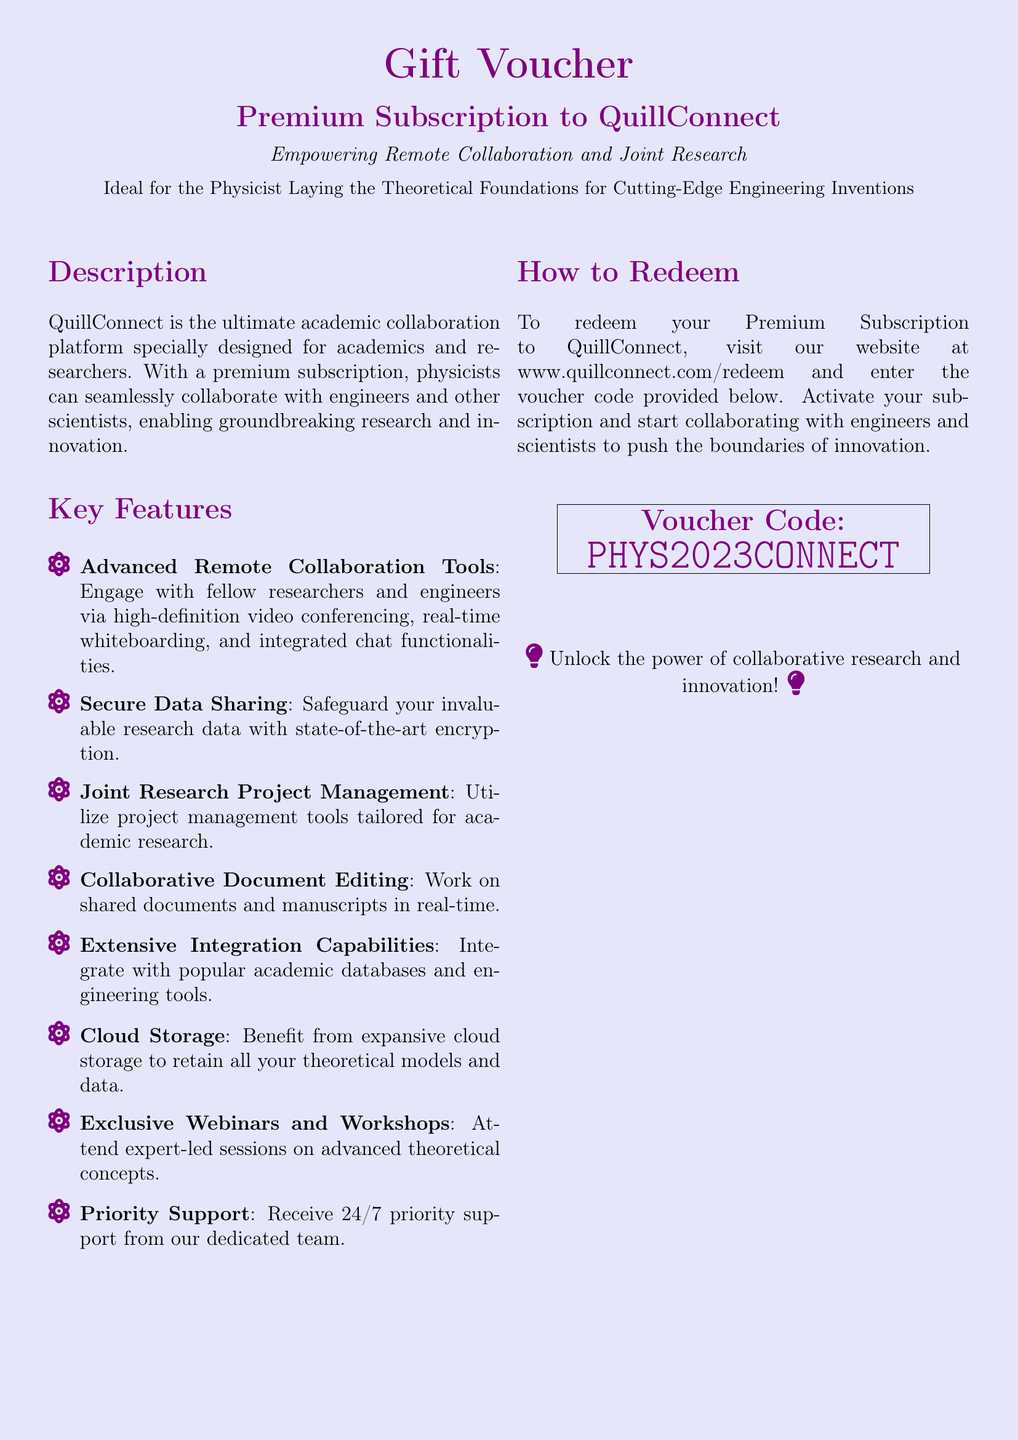What is the name of the platform? The document specifies the name of the platform as QuillConnect.
Answer: QuillConnect What is the voucher code? The voucher code provided for redeeming is explicitly mentioned in the document.
Answer: PHYS2023CONNECT What type of support is available for users? The document states that 24/7 priority support is available for users of QuillConnect.
Answer: Priority support What is one of the key features of QuillConnect? The document lists multiple key features, including secure data sharing among others.
Answer: Secure data sharing How can the voucher be redeemed? The document describes the redemption process which includes visiting a specific website.
Answer: www.quillconnect.com/redeem What is the target audience for this gift voucher? The document mentions that the voucher is ideal for physicists laying theoretical foundations.
Answer: Physicists What type of collaboration tools does QuillConnect provide? The document mentions that it includes advanced remote collaboration tools.
Answer: Advanced remote collaboration tools What is one benefit of using QuillConnect for researchers? The document lists that it empowers remote collaboration and joint research.
Answer: Empowering remote collaboration and joint research 